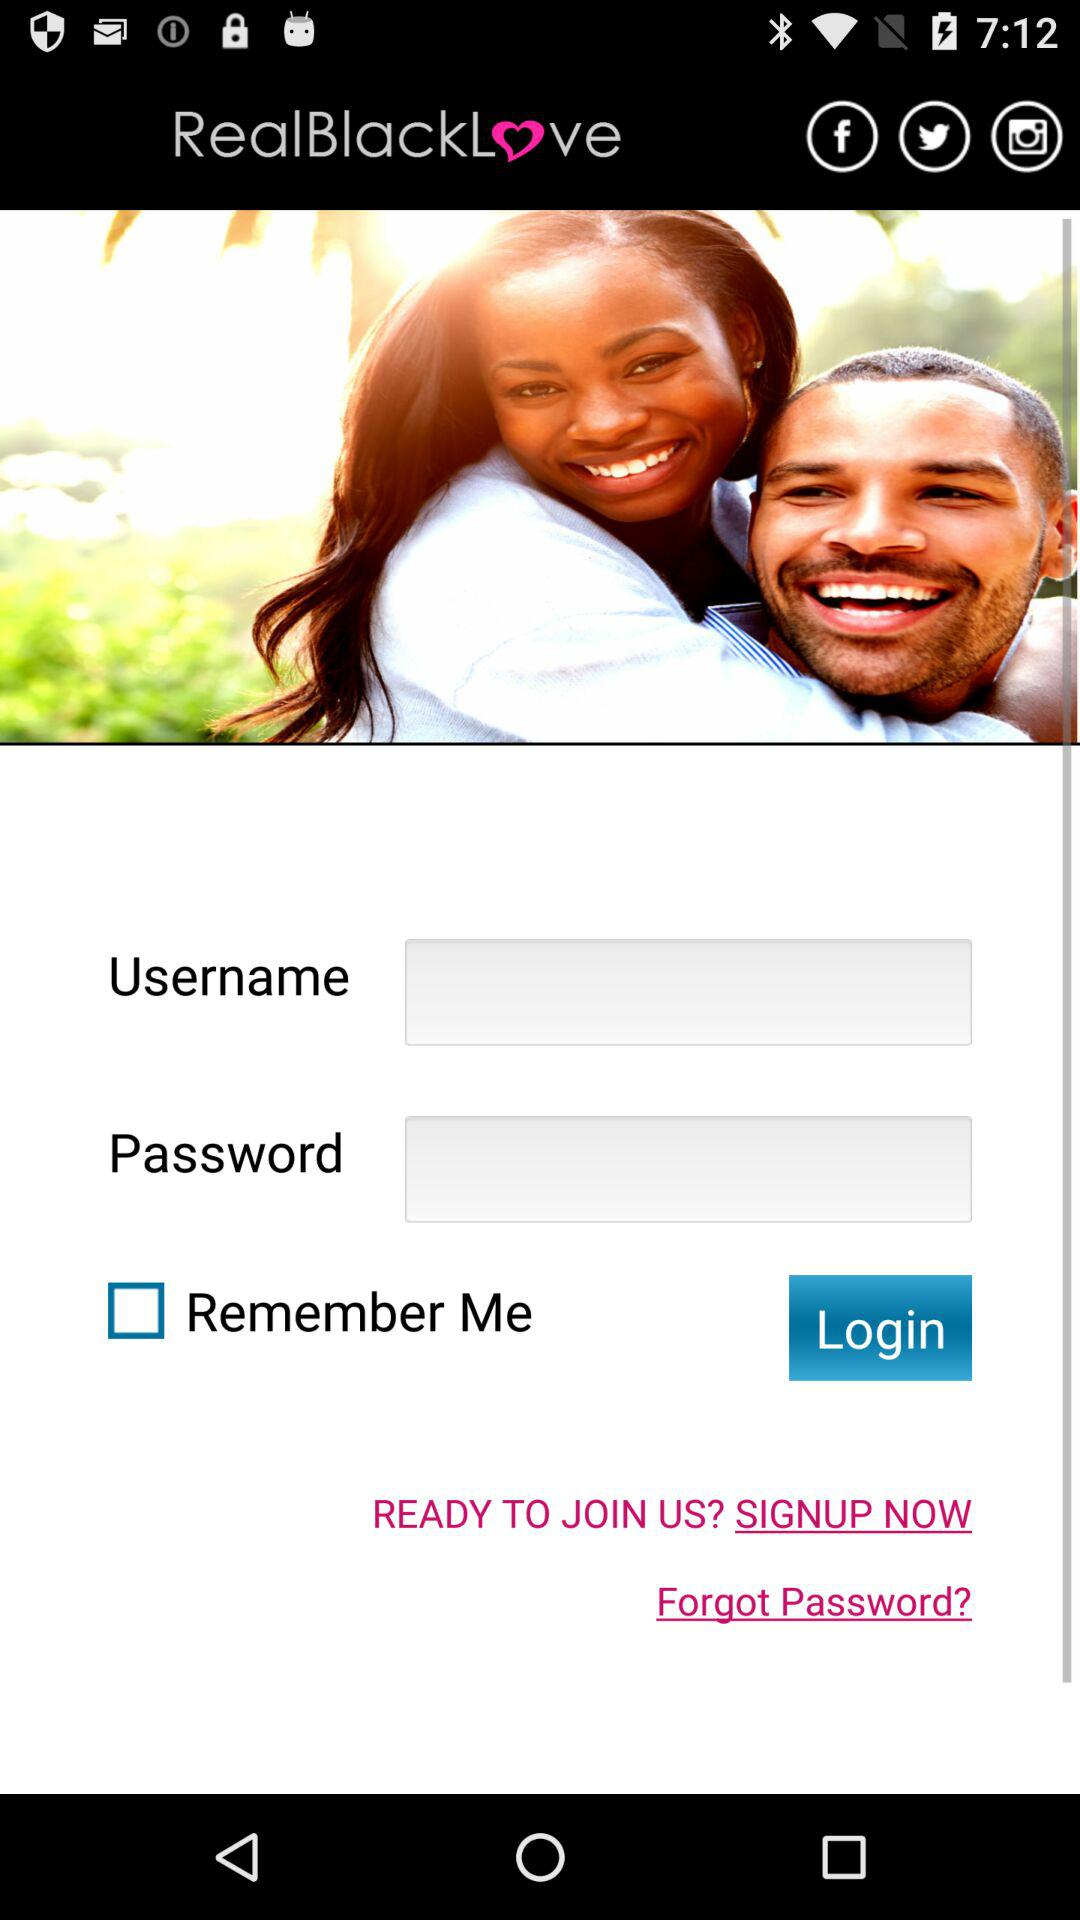Can we reset password?
When the provided information is insufficient, respond with <no answer>. <no answer> 